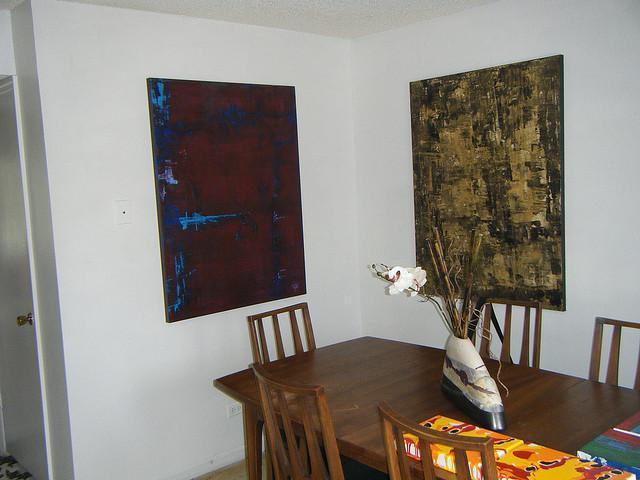How many chairs are seen in the picture?
Give a very brief answer. 5. How many chairs are there?
Give a very brief answer. 5. 